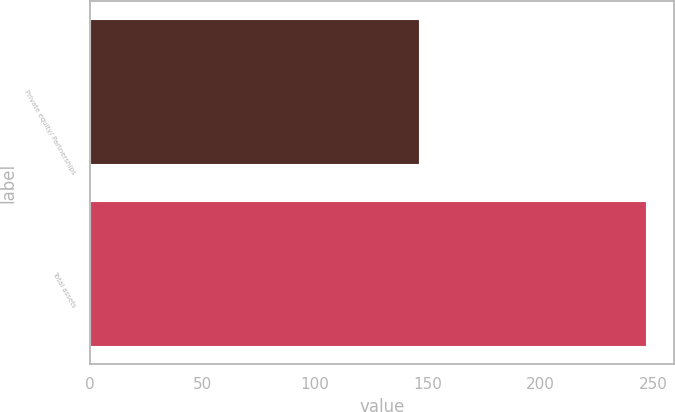Convert chart. <chart><loc_0><loc_0><loc_500><loc_500><bar_chart><fcel>Private equity/ Partnerships<fcel>Total assets<nl><fcel>146<fcel>247<nl></chart> 